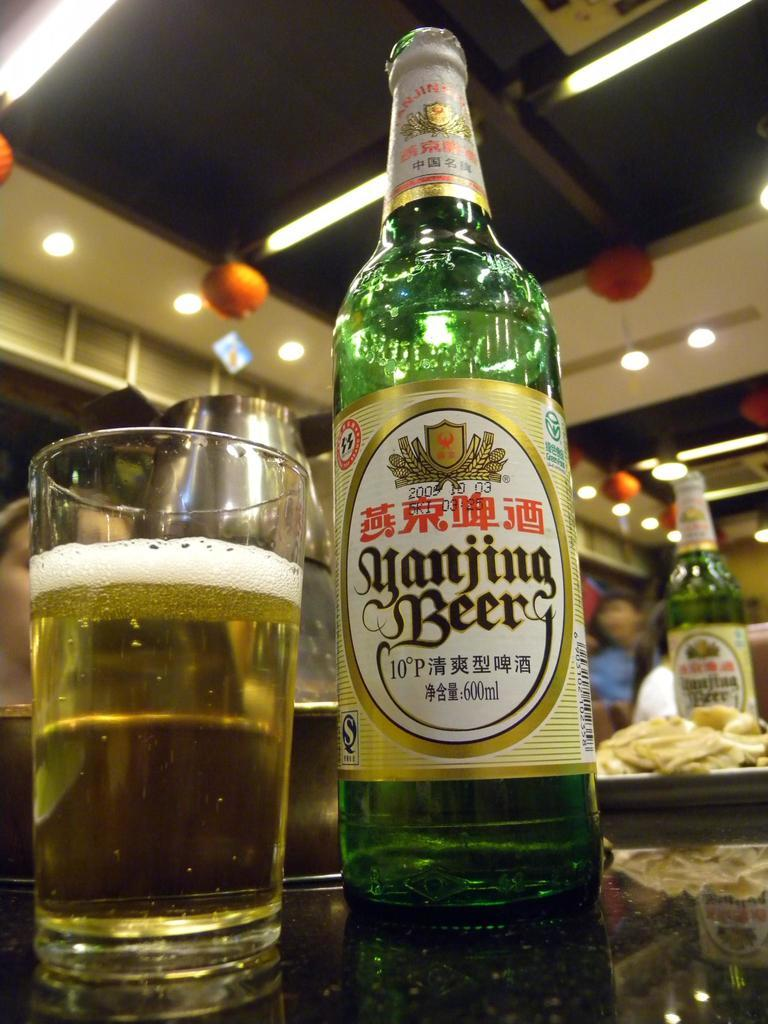What is there is a bottle and a glass in the image. Can you describe the bottle? The bottle is an object visible in the image. What can you tell me about the glass in the image? The glass is another object visible in the image. Is there a kite flying in the background of the image? There is no mention of a kite or any background in the provided facts, so it cannot be determined from the image. 